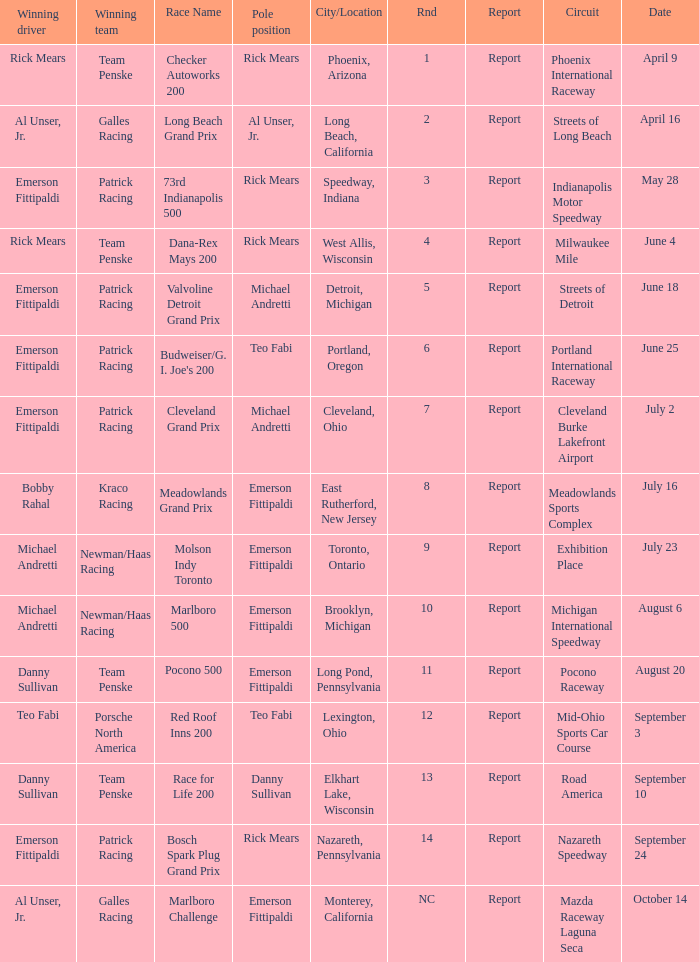Parse the full table. {'header': ['Winning driver', 'Winning team', 'Race Name', 'Pole position', 'City/Location', 'Rnd', 'Report', 'Circuit', 'Date'], 'rows': [['Rick Mears', 'Team Penske', 'Checker Autoworks 200', 'Rick Mears', 'Phoenix, Arizona', '1', 'Report', 'Phoenix International Raceway', 'April 9'], ['Al Unser, Jr.', 'Galles Racing', 'Long Beach Grand Prix', 'Al Unser, Jr.', 'Long Beach, California', '2', 'Report', 'Streets of Long Beach', 'April 16'], ['Emerson Fittipaldi', 'Patrick Racing', '73rd Indianapolis 500', 'Rick Mears', 'Speedway, Indiana', '3', 'Report', 'Indianapolis Motor Speedway', 'May 28'], ['Rick Mears', 'Team Penske', 'Dana-Rex Mays 200', 'Rick Mears', 'West Allis, Wisconsin', '4', 'Report', 'Milwaukee Mile', 'June 4'], ['Emerson Fittipaldi', 'Patrick Racing', 'Valvoline Detroit Grand Prix', 'Michael Andretti', 'Detroit, Michigan', '5', 'Report', 'Streets of Detroit', 'June 18'], ['Emerson Fittipaldi', 'Patrick Racing', "Budweiser/G. I. Joe's 200", 'Teo Fabi', 'Portland, Oregon', '6', 'Report', 'Portland International Raceway', 'June 25'], ['Emerson Fittipaldi', 'Patrick Racing', 'Cleveland Grand Prix', 'Michael Andretti', 'Cleveland, Ohio', '7', 'Report', 'Cleveland Burke Lakefront Airport', 'July 2'], ['Bobby Rahal', 'Kraco Racing', 'Meadowlands Grand Prix', 'Emerson Fittipaldi', 'East Rutherford, New Jersey', '8', 'Report', 'Meadowlands Sports Complex', 'July 16'], ['Michael Andretti', 'Newman/Haas Racing', 'Molson Indy Toronto', 'Emerson Fittipaldi', 'Toronto, Ontario', '9', 'Report', 'Exhibition Place', 'July 23'], ['Michael Andretti', 'Newman/Haas Racing', 'Marlboro 500', 'Emerson Fittipaldi', 'Brooklyn, Michigan', '10', 'Report', 'Michigan International Speedway', 'August 6'], ['Danny Sullivan', 'Team Penske', 'Pocono 500', 'Emerson Fittipaldi', 'Long Pond, Pennsylvania', '11', 'Report', 'Pocono Raceway', 'August 20'], ['Teo Fabi', 'Porsche North America', 'Red Roof Inns 200', 'Teo Fabi', 'Lexington, Ohio', '12', 'Report', 'Mid-Ohio Sports Car Course', 'September 3'], ['Danny Sullivan', 'Team Penske', 'Race for Life 200', 'Danny Sullivan', 'Elkhart Lake, Wisconsin', '13', 'Report', 'Road America', 'September 10'], ['Emerson Fittipaldi', 'Patrick Racing', 'Bosch Spark Plug Grand Prix', 'Rick Mears', 'Nazareth, Pennsylvania', '14', 'Report', 'Nazareth Speedway', 'September 24'], ['Al Unser, Jr.', 'Galles Racing', 'Marlboro Challenge', 'Emerson Fittipaldi', 'Monterey, California', 'NC', 'Report', 'Mazda Raceway Laguna Seca', 'October 14']]} What rnds were there for the phoenix international raceway? 1.0. 